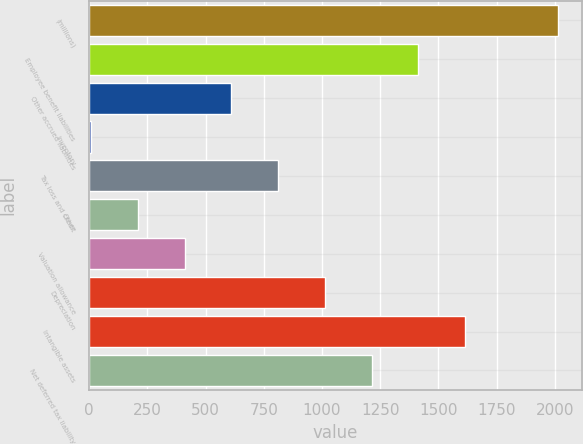Convert chart to OTSL. <chart><loc_0><loc_0><loc_500><loc_500><bar_chart><fcel>(millions)<fcel>Employee benefit liabilities<fcel>Other accrued liabilities<fcel>Inventory<fcel>Tax loss and credit<fcel>Other<fcel>Valuation allowance<fcel>Depreciation<fcel>Intangible assets<fcel>Net deferred tax liability<nl><fcel>2015<fcel>1413.32<fcel>611.08<fcel>9.4<fcel>811.64<fcel>209.96<fcel>410.52<fcel>1012.2<fcel>1613.88<fcel>1212.76<nl></chart> 